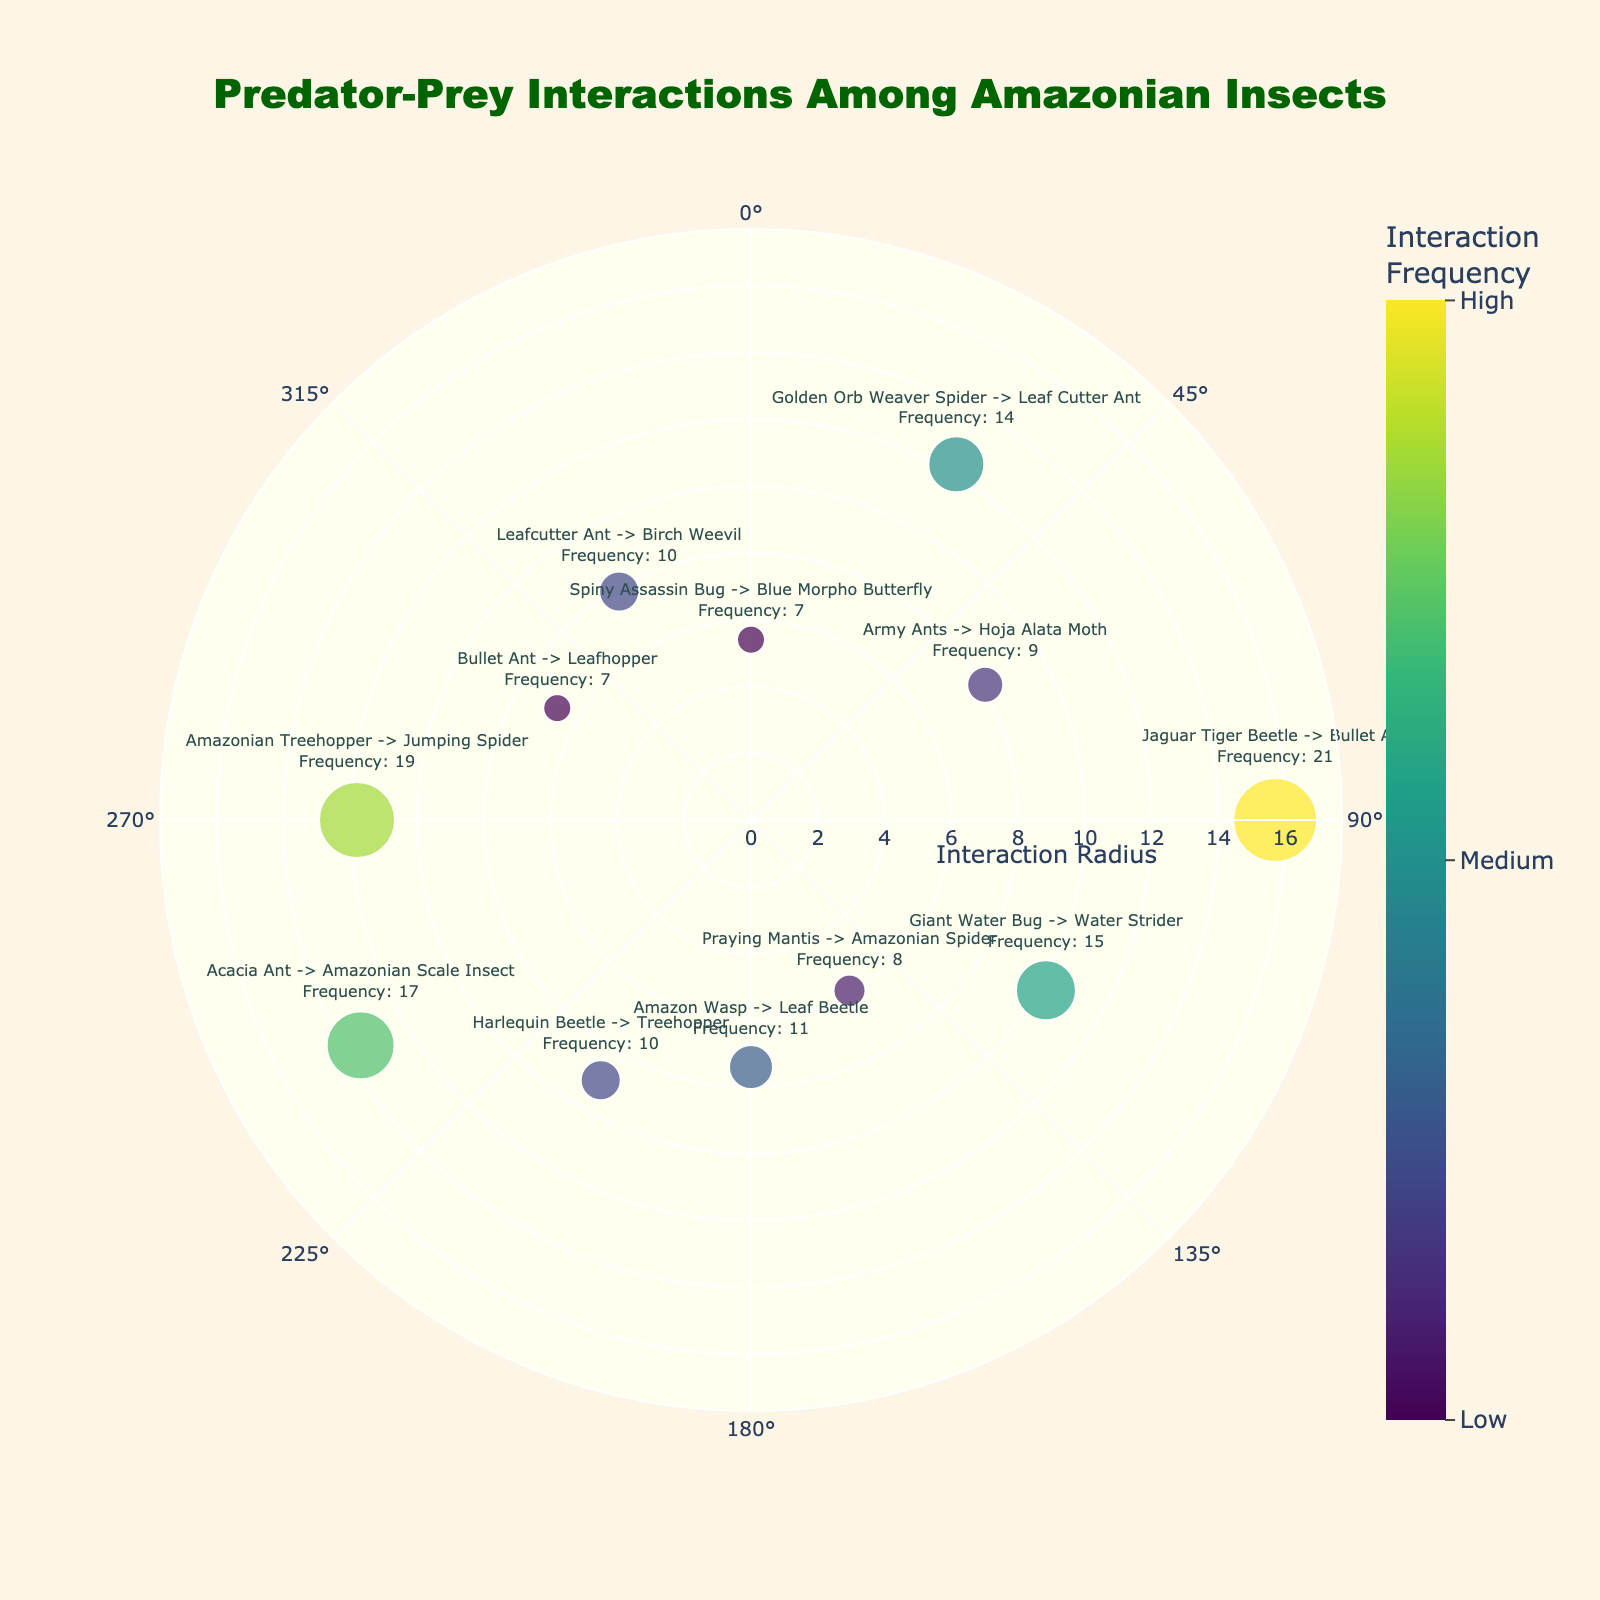What is the title of the polar scatter chart? The title is displayed at the top of the chart. It reads "Predator-Prey Interactions Among Amazonian Insects".
Answer: Predator-Prey Interactions Among Amazonian Insects How many interaction points are plotted on the chart? The chart has different markers for each interaction. Counting these markers, there are 12 interaction points.
Answer: 12 Which predator has the highest interaction frequency? By looking at the markers and the color scale, the darkest and largest marker represents the highest frequency. The Jaguar Tiger Beetle with a radius of 15.7 and interaction frequency of 21 is the highest.
Answer: Jaguar Tiger Beetle What is the interaction frequency of the Army Ants? Each marker's text includes the predator, prey, and frequency. The marker for Army Ants points to an interaction frequency of 9.
Answer: 9 Which interaction point is closest to the center and why? The center is at radius 0. The smallest radius value indicates the closest point to the center. The Spiny Assassin Bug-Blue Morpho Butterfly interaction at radius 5.4 is the closest.
Answer: Spiny Assassin Bug-Blue Morpho Butterfly What is the average interaction frequency of the interactions involving ants (Army Ants, Bullet Ant, Acacia Ant, Leafcutter Ant)? Summing the frequencies for Army Ants (9), Bullet Ant (7), Acacia Ant (17), and Leafcutter Ant (10) gives 43. Dividing by 4 (number of points) gives an average: 43/4 = 10.75.
Answer: 10.75 Compare the interaction frequencies between the Amazonian Treehopper and the Golden Orb Weaver Spider. Which one has a higher frequency, and by how much? The Amazonian Treehopper has a frequency of 19 and the Golden Orb Weaver Spider has 14. The difference is 19 - 14.
Answer: Amazonian Treehopper by 5 What is the median interaction frequency of all the plotted interactions? Sorting frequencies: 7, 7, 8, 9, 10, 10, 11, 14, 15, 17, 19, 21. The median is the average of 10 and 11, the middle two values: (10+11)/2 = 10.5.
Answer: 10.5 At which angle does the Praying Mantis-Amazonian Spider interaction occur? The interaction is marked and labeled; looking up the angle for Praying Mantis and Amazonian Spider shows it is 150 degrees.
Answer: 150 degrees Which predator-prey interaction takes place at an angle of 240 degrees and what is its frequency? By checking the angle labels, the interaction at 240 degrees involves the Acacia Ant and Amazonian Scale Insect with a frequency of 17.
Answer: Acacia Ant-Amazonian Scale Insect, 17 